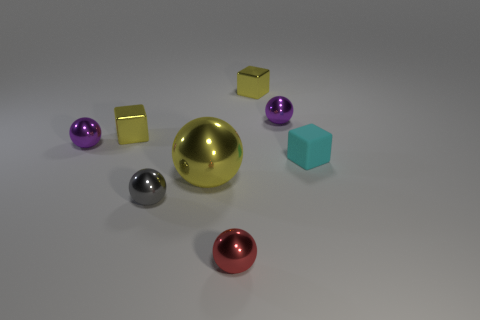Are there any other things that are the same size as the yellow ball?
Your answer should be compact. No. Are there any tiny gray objects made of the same material as the yellow sphere?
Your answer should be very brief. Yes. There is a tiny red shiny thing; is its shape the same as the yellow object to the right of the tiny red ball?
Make the answer very short. No. There is a small gray object; are there any tiny things right of it?
Ensure brevity in your answer.  Yes. What number of other small metallic objects are the same shape as the cyan thing?
Offer a very short reply. 2. Does the big yellow ball have the same material as the tiny purple thing to the left of the red metallic thing?
Offer a very short reply. Yes. What number of red metal objects are there?
Your response must be concise. 1. What is the size of the yellow metal object in front of the cyan matte cube?
Your answer should be compact. Large. What number of spheres are the same size as the red shiny object?
Provide a succinct answer. 3. What material is the cyan cube that is the same size as the red sphere?
Your answer should be very brief. Rubber. 